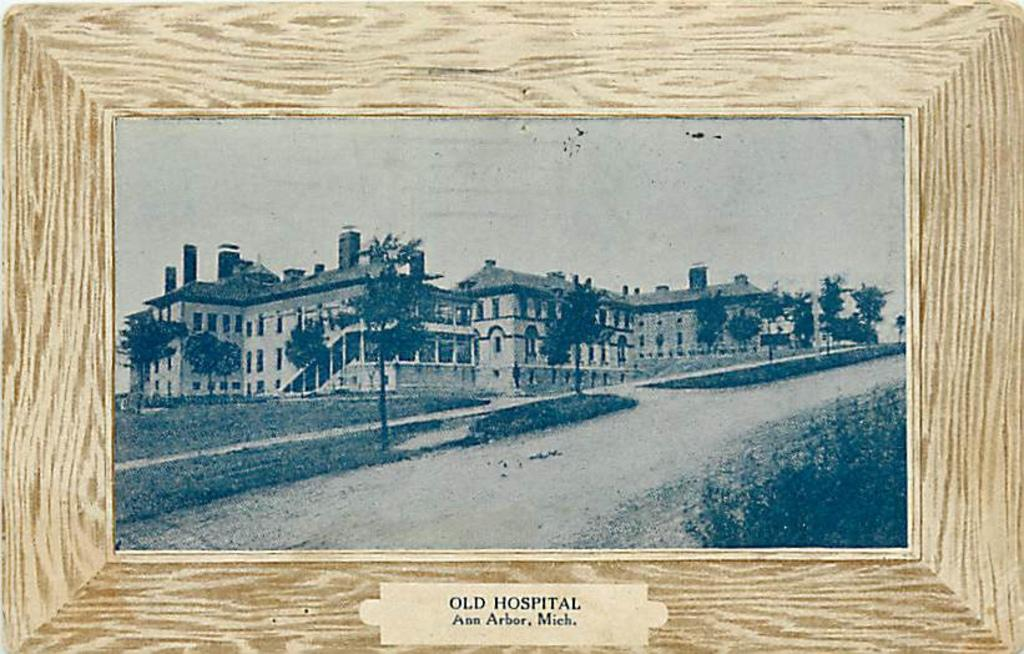<image>
Write a terse but informative summary of the picture. a frame that has old hospital written on it 